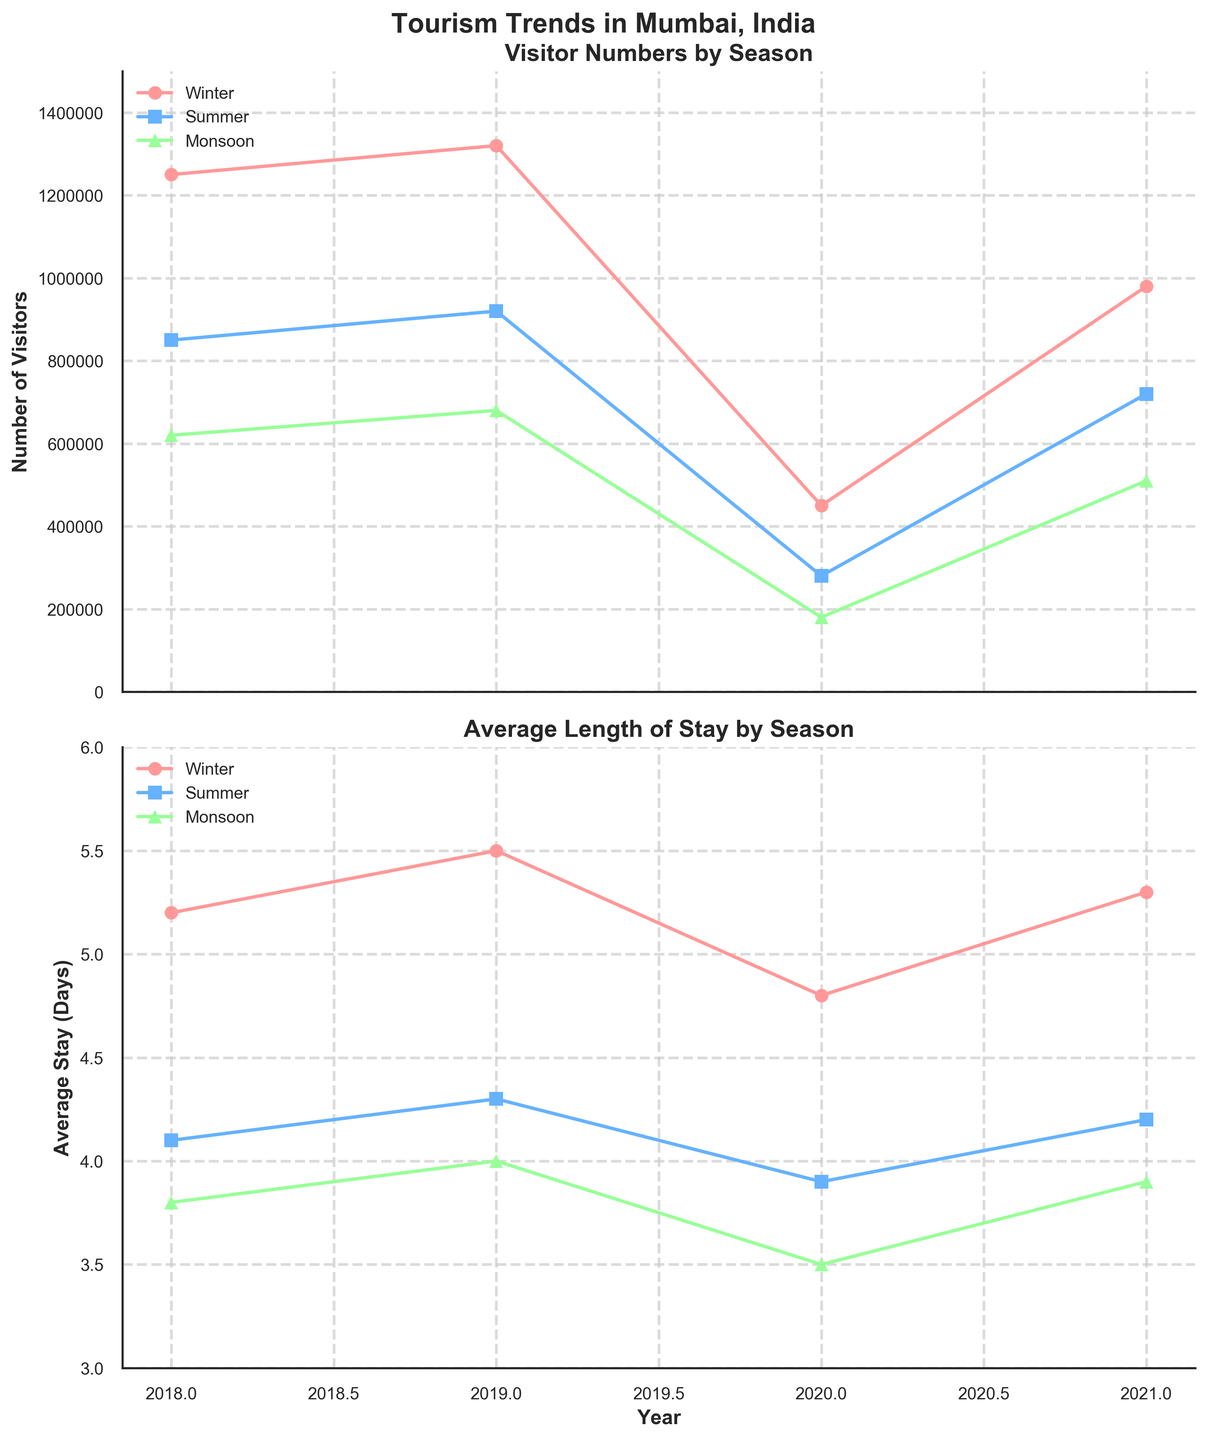What are the two subplots shown in the figure? The figure consists of two subplots. One plot shows "Visitor Numbers by Season" and the other plot shows "Average Length of Stay by Season".
Answer: Visitor Numbers by Season and Average Length of Stay by Season How many data points are there for each season in the figure? Each season has data points for four years: 2018, 2019, 2020, and 2021, resulting in 4 data points per season.
Answer: 4 Which season had the highest number of visitors in 2019? By looking at the "Visitor Numbers by Season" subplot for the year 2019, it's clear that Winter had the highest number of visitors, which is 1,320,000.
Answer: Winter How does the average length of stay in Winter change from 2018 to 2021? In the Winter season, the average stay increased from 5.2 days in 2018 to 5.5 days in 2019, then decreased to 4.8 days in 2020, and finally increased to 5.3 days in 2021.
Answer: It increased, then decreased, then increased Compare the number of visitors during Monsoon and Summer in 2021. Which season had more visitors? For 2021, the "Visitor Numbers by Season" subplot shows that Summer had 720,000 visitors while Monsoon had 510,000 visitors.
Answer: Summer By how much did the number of visitors during Summer decrease in 2020 compared to 2019? In 2019, Summer had 920,000 visitors, and in 2020, the number dropped to 280,000. Thus, the decrease is 920,000 - 280,000 = 640,000 visitors.
Answer: By 640,000 visitors What is the average length of stay for the Monsoon season over the four years? The average stay lengths for Monsoon are: 2018: 3.8 days, 2019: 4.0 days, 2020: 3.5 days, and 2021: 3.9 days. The average is (3.8 + 4.0 + 3.5 + 3.9) / 4 = 3.8 days.
Answer: 3.8 days Which season had the least average length of stay in 2020? As per the "Average Length of Stay by Season" subplot for 2020, Monsoon had the least average stay of 3.5 days.
Answer: Monsoon How did the visitor trends change overall from 2018 to 2020? The trends show a significant dip in visitor numbers for all seasons in 2020: Winter from 1,320,000 to 450,000, Summer from 920,000 to 280,000, and Monsoon from 680,000 to 180,000. This dip is likely due to external factors such as the pandemic.
Answer: Significant decrease Between which years did Winter experience the biggest drop in visitor numbers? Observing the "Visitor Numbers by Season" subplot for Winter, the biggest drop was between 2019 (1,320,000 visitors) and 2020 (450,000 visitors).
Answer: Between 2019 and 2020 